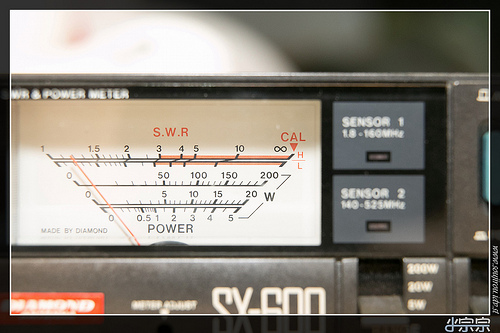<image>
Is the numbers on the sensor? Yes. Looking at the image, I can see the numbers is positioned on top of the sensor, with the sensor providing support. 